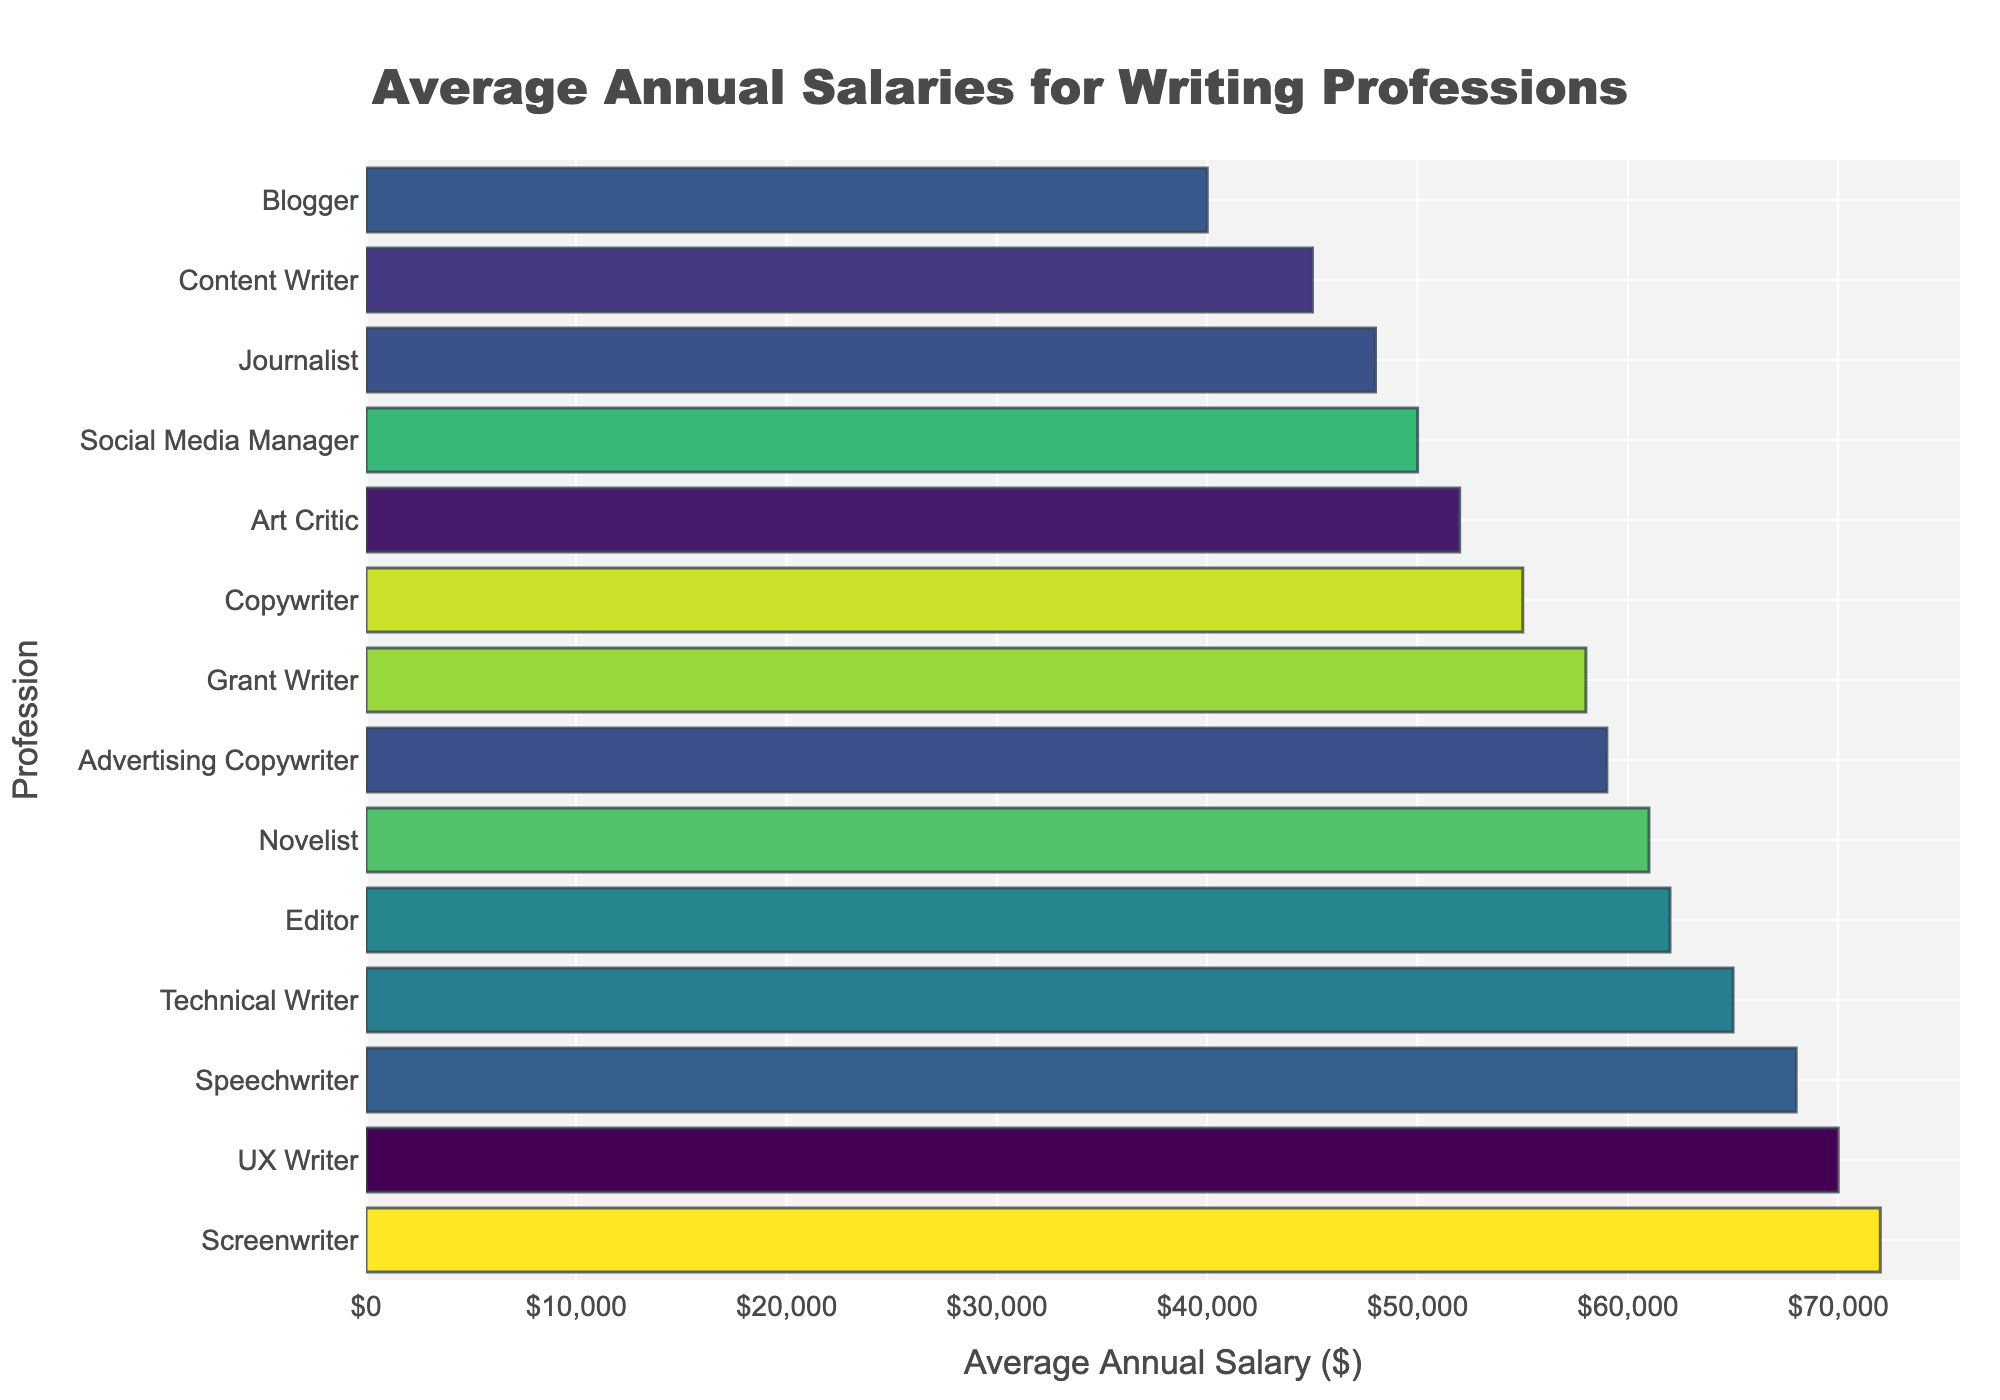What is the average annual salary of the highest-paid profession in the chart? The highest-paid profession is the one with the longest bar on the right end of the chart. From the visual, it appears to be the Screenwriter. By checking the corresponding salary value on the x-axis, we find that the Screenwriter's salary is $72,000.
Answer: $72,000 What is the difference in average annual salary between a Novelist and a Blogger? First, identify the bars for Novelist and Blogger. The Novelist has a salary of $61,000, and the Blogger has a salary of $40,000. Subtract the Blogger's salary from the Novelist's salary: $61,000 - $40,000 = $21,000.
Answer: $21,000 Which profession has a higher average annual salary: Technical Writer or Copywriter? Find the positions of Technical Writer and Copywriter on the chart. The Technical Writer has a salary of $65,000 and the Copywriter has a salary of $55,000. Since $65,000 is greater than $55,000, the Technical Writer has a higher salary.
Answer: Technical Writer By how much is the average annual salary of an Editor higher than that of a Social Media Manager? The bar lengths for Editor and Social Media Manager show their salaries as $62,000 and $50,000 respectively. So, the difference is $62,000 - $50,000 = $12,000.
Answer: $12,000 What is the combined average annual salary of a Speechwriter, Advertising Copywriter, and Grant Writer? Identify the bars for Speechwriter, Advertising Copywriter, and Grant Writer. Their salaries are $68,000, $59,000, and $58,000 respectively. Sum these values: $68,000 + $59,000 + $58,000 = $185,000.
Answer: $185,000 Which profession is positioned exactly in the middle when the chart is sorted by salary? The chart is sorted in descending order by salary. There are 14 professions, so the middle one is the 7th. Counting from the top, the 7th profession is Grant Writer.
Answer: Grant Writer What is the range of average annual salaries across all professions? The range is calculated by subtracting the smallest value from the largest value in the chart. The lowest salary is $40,000 (Blogger), and the highest is $72,000 (Screenwriter). So, the range is $72,000 - $40,000 = $32,000.
Answer: $32,000 How many professions have an average annual salary greater than $60,000? Count the number of bars that extend past the $60,000 mark. These professions are Technical Writer, Screenwriter, Novelist, Editor, Speechwriter, UX Writer, and Advertising Copywriter. This makes a total of 7 professions.
Answer: 7 